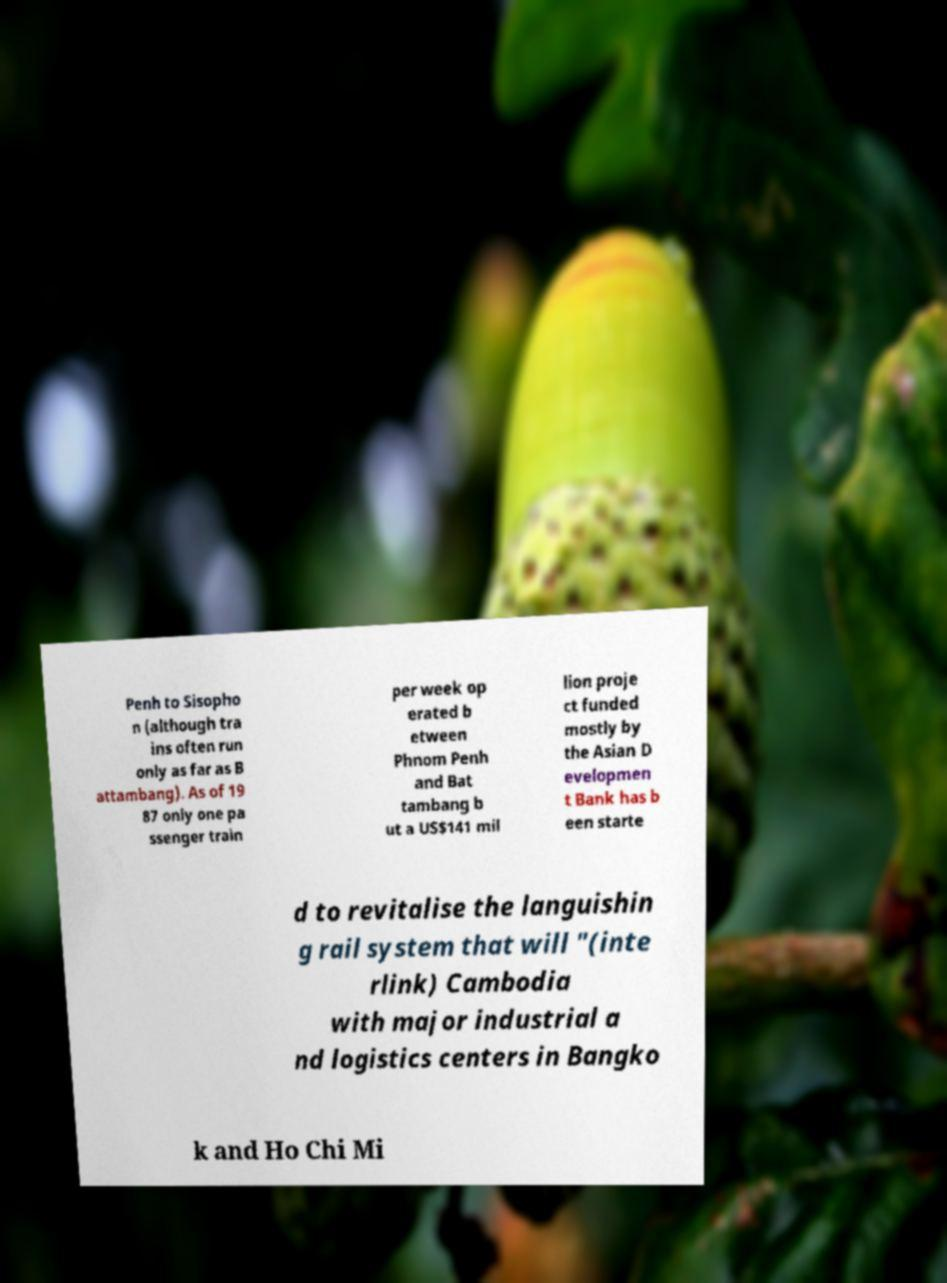Could you extract and type out the text from this image? Penh to Sisopho n (although tra ins often run only as far as B attambang). As of 19 87 only one pa ssenger train per week op erated b etween Phnom Penh and Bat tambang b ut a US$141 mil lion proje ct funded mostly by the Asian D evelopmen t Bank has b een starte d to revitalise the languishin g rail system that will "(inte rlink) Cambodia with major industrial a nd logistics centers in Bangko k and Ho Chi Mi 